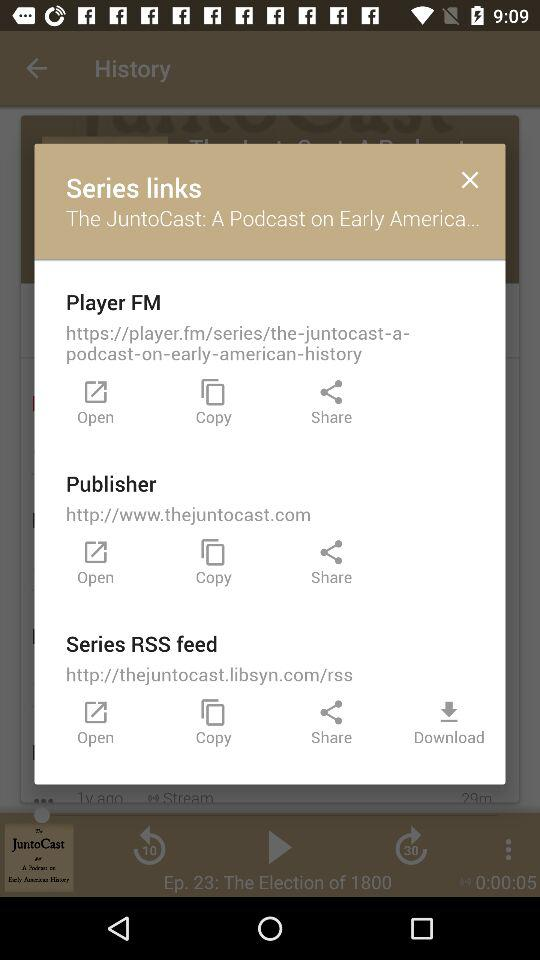How many links are there on this screen?
Answer the question using a single word or phrase. 3 